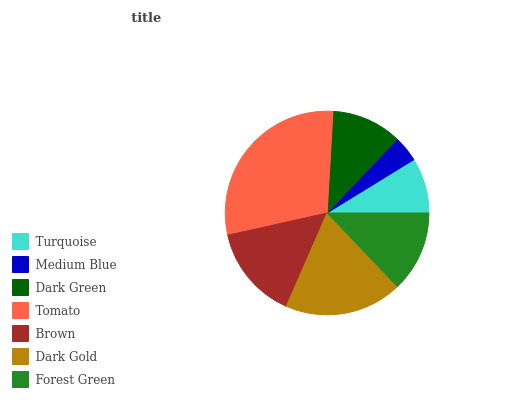Is Medium Blue the minimum?
Answer yes or no. Yes. Is Tomato the maximum?
Answer yes or no. Yes. Is Dark Green the minimum?
Answer yes or no. No. Is Dark Green the maximum?
Answer yes or no. No. Is Dark Green greater than Medium Blue?
Answer yes or no. Yes. Is Medium Blue less than Dark Green?
Answer yes or no. Yes. Is Medium Blue greater than Dark Green?
Answer yes or no. No. Is Dark Green less than Medium Blue?
Answer yes or no. No. Is Forest Green the high median?
Answer yes or no. Yes. Is Forest Green the low median?
Answer yes or no. Yes. Is Turquoise the high median?
Answer yes or no. No. Is Dark Gold the low median?
Answer yes or no. No. 